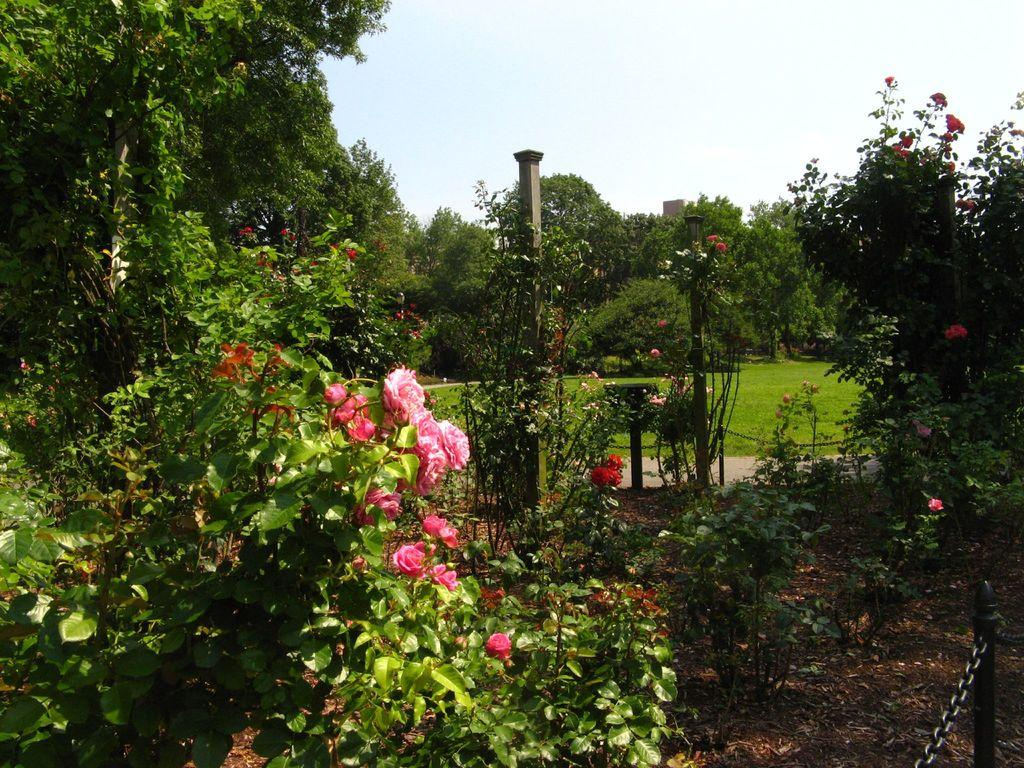What type of vegetation can be seen in the image? There are trees, grass, plants, and flowers in the image. What structure is present in the image? There is a pillar in the image. What type of lighting is visible in the image? There are lights in the image. What are the tiny poles used for in the image? The tiny poles are not mentioned in the provided facts, so we cannot determine their purpose from the image. What year is depicted in the image? The provided facts do not mention any specific year, so we cannot determine the year from the image. What type of hose can be seen in the image? There is no hose present in the image. 